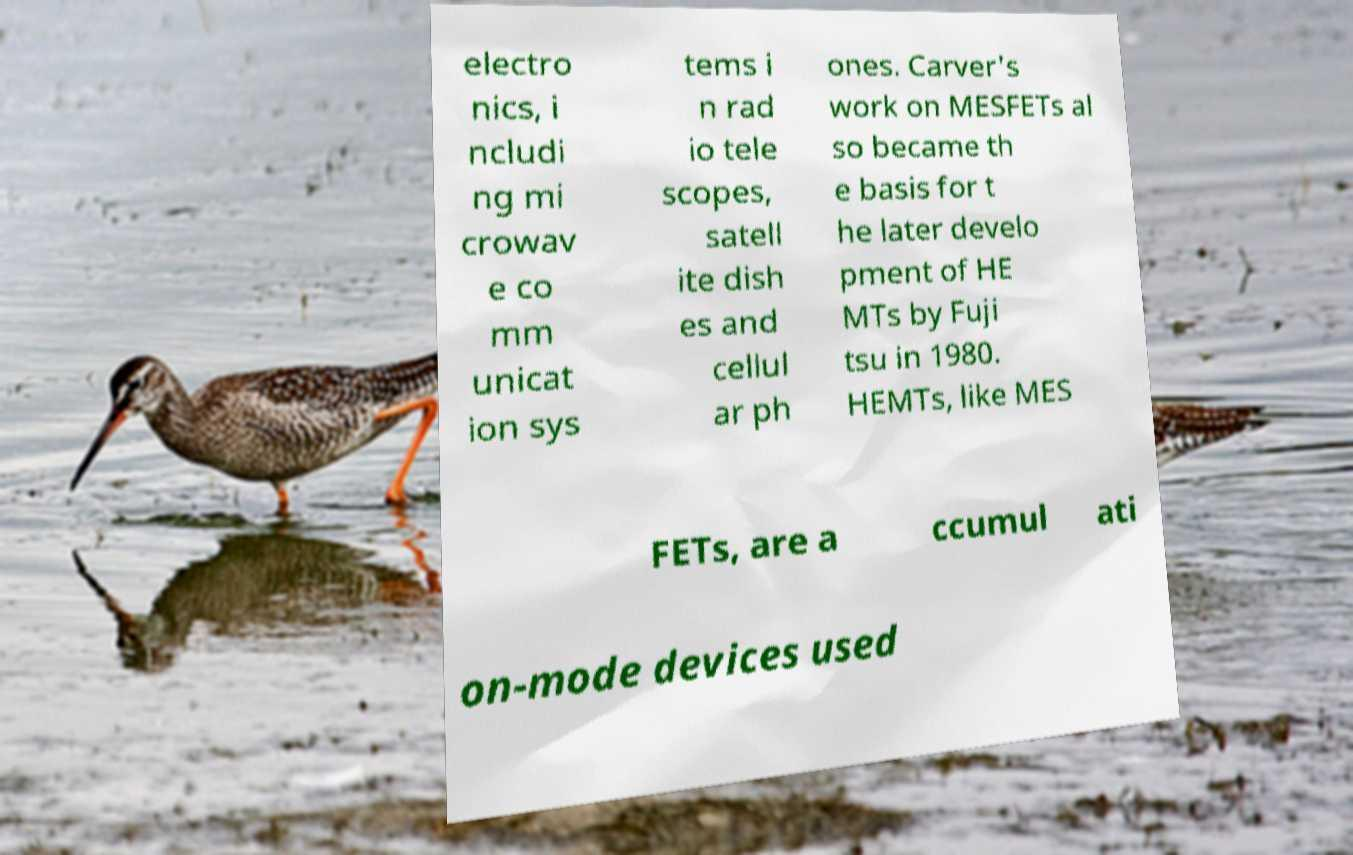Please read and relay the text visible in this image. What does it say? electro nics, i ncludi ng mi crowav e co mm unicat ion sys tems i n rad io tele scopes, satell ite dish es and cellul ar ph ones. Carver's work on MESFETs al so became th e basis for t he later develo pment of HE MTs by Fuji tsu in 1980. HEMTs, like MES FETs, are a ccumul ati on-mode devices used 